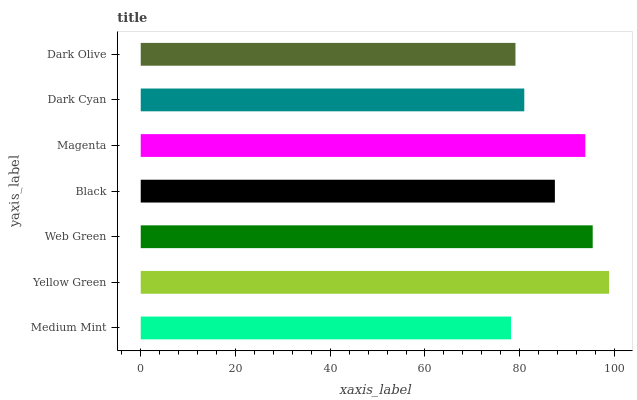Is Medium Mint the minimum?
Answer yes or no. Yes. Is Yellow Green the maximum?
Answer yes or no. Yes. Is Web Green the minimum?
Answer yes or no. No. Is Web Green the maximum?
Answer yes or no. No. Is Yellow Green greater than Web Green?
Answer yes or no. Yes. Is Web Green less than Yellow Green?
Answer yes or no. Yes. Is Web Green greater than Yellow Green?
Answer yes or no. No. Is Yellow Green less than Web Green?
Answer yes or no. No. Is Black the high median?
Answer yes or no. Yes. Is Black the low median?
Answer yes or no. Yes. Is Dark Cyan the high median?
Answer yes or no. No. Is Dark Cyan the low median?
Answer yes or no. No. 